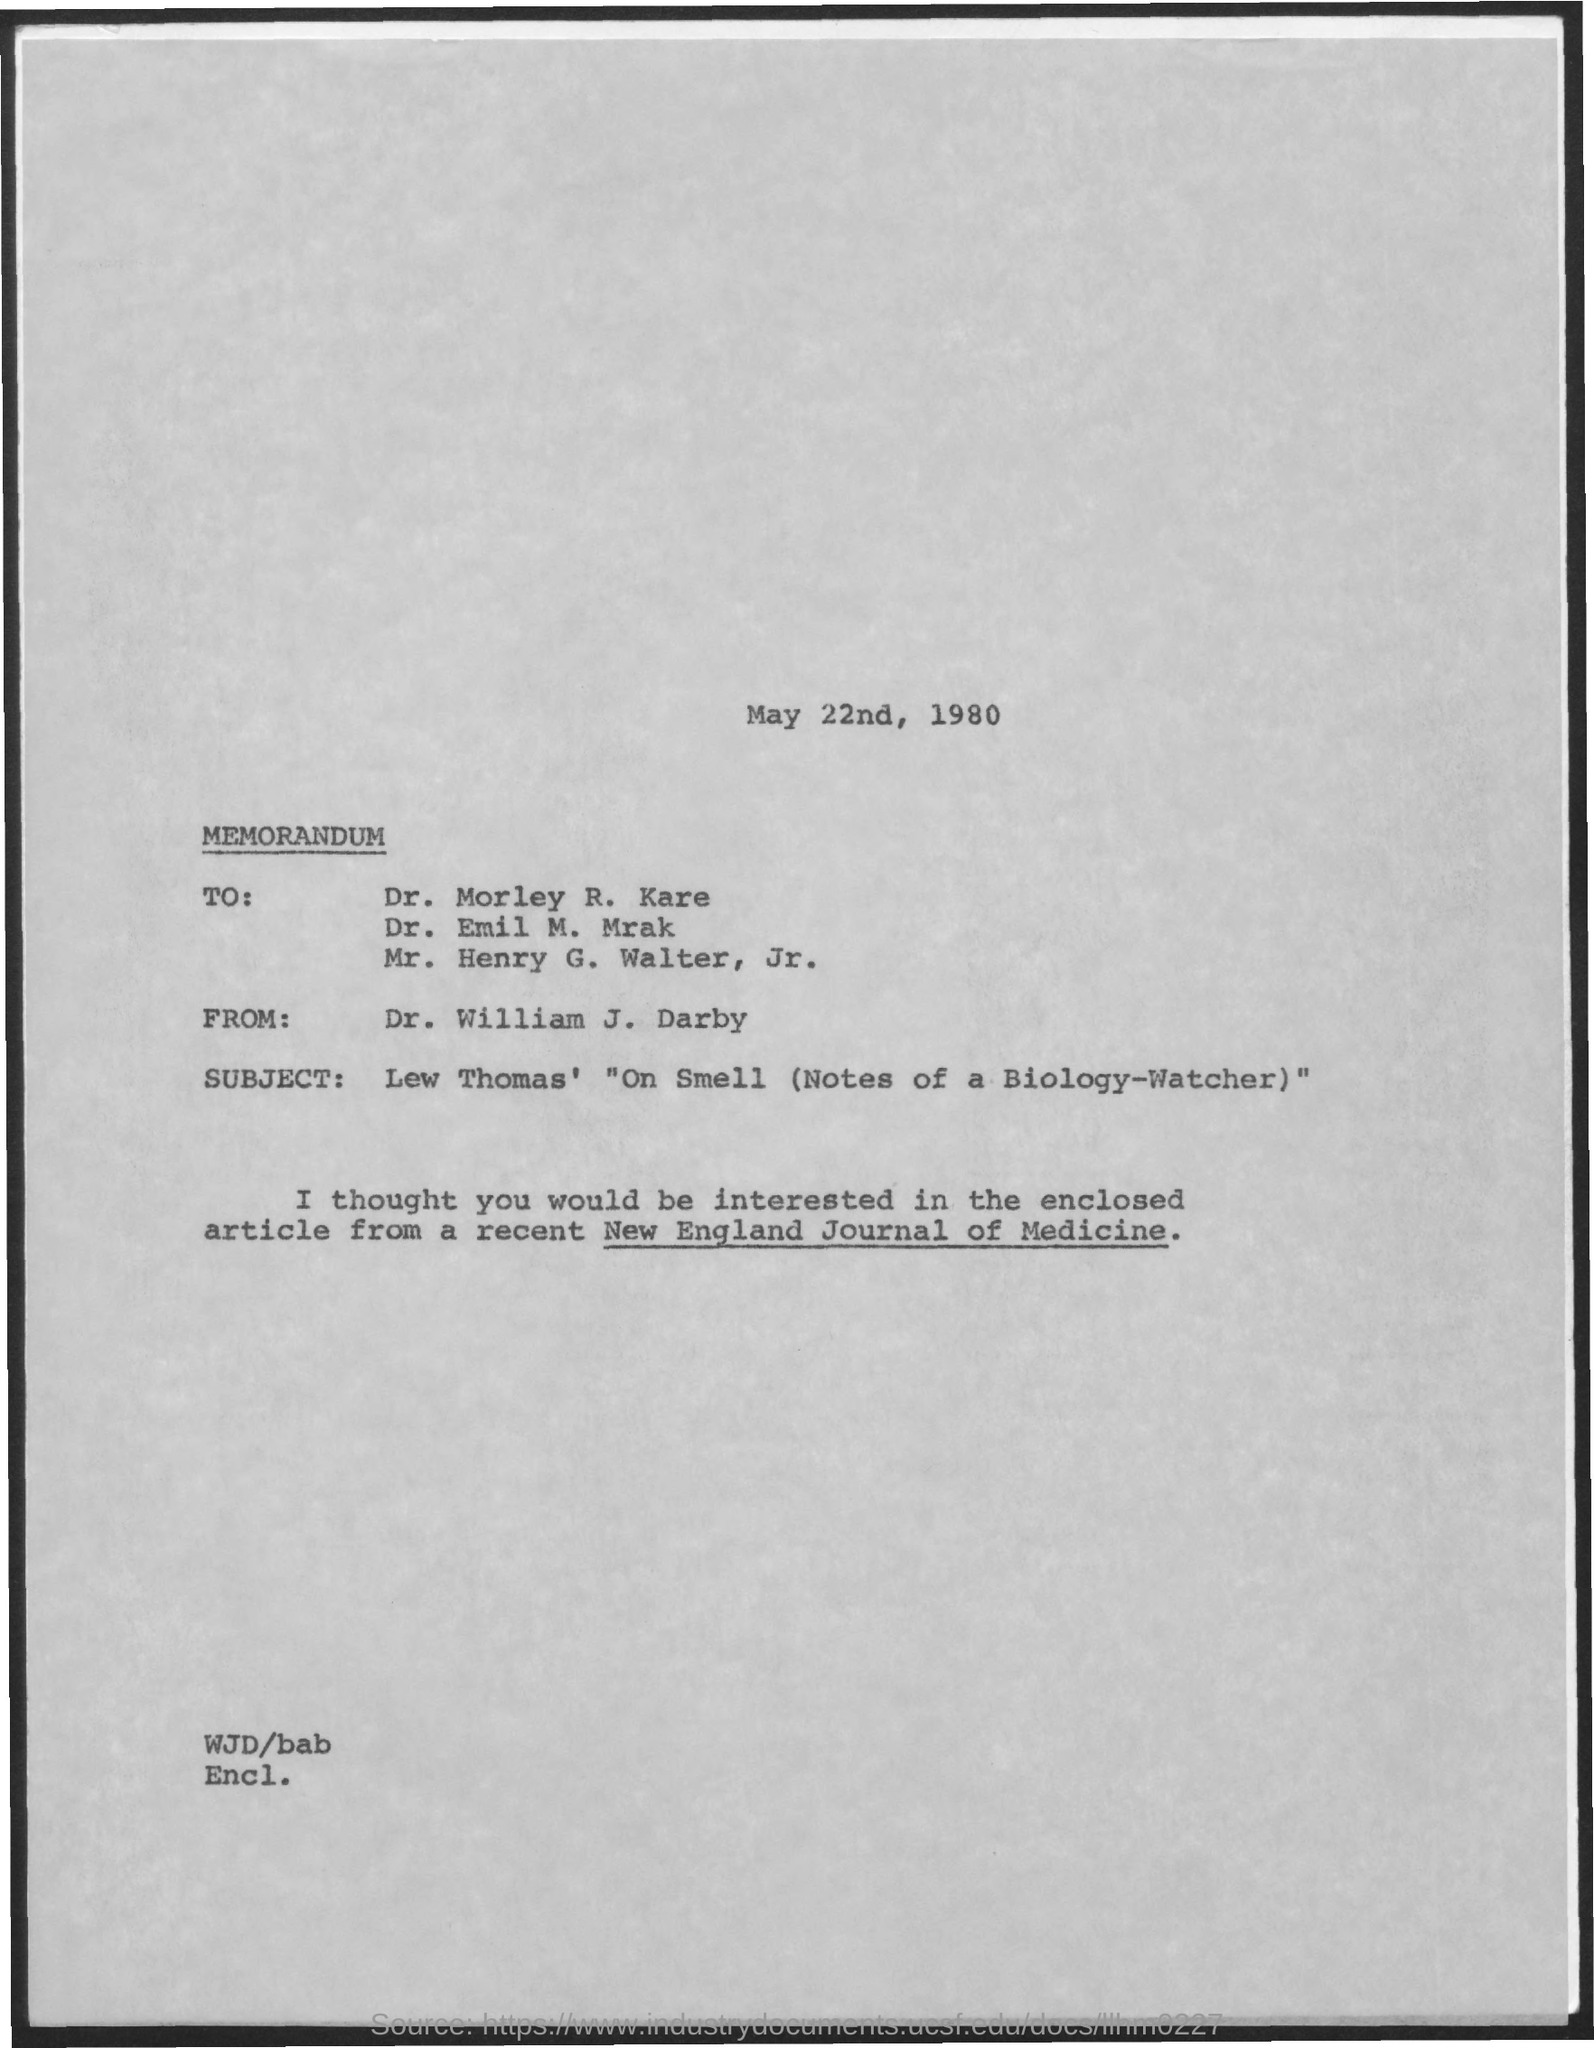The Memorandum is from which person?
Offer a terse response. Dr. William J. Darby. What is the date mentioned in the document?
Your answer should be compact. May 22nd, 1980. 